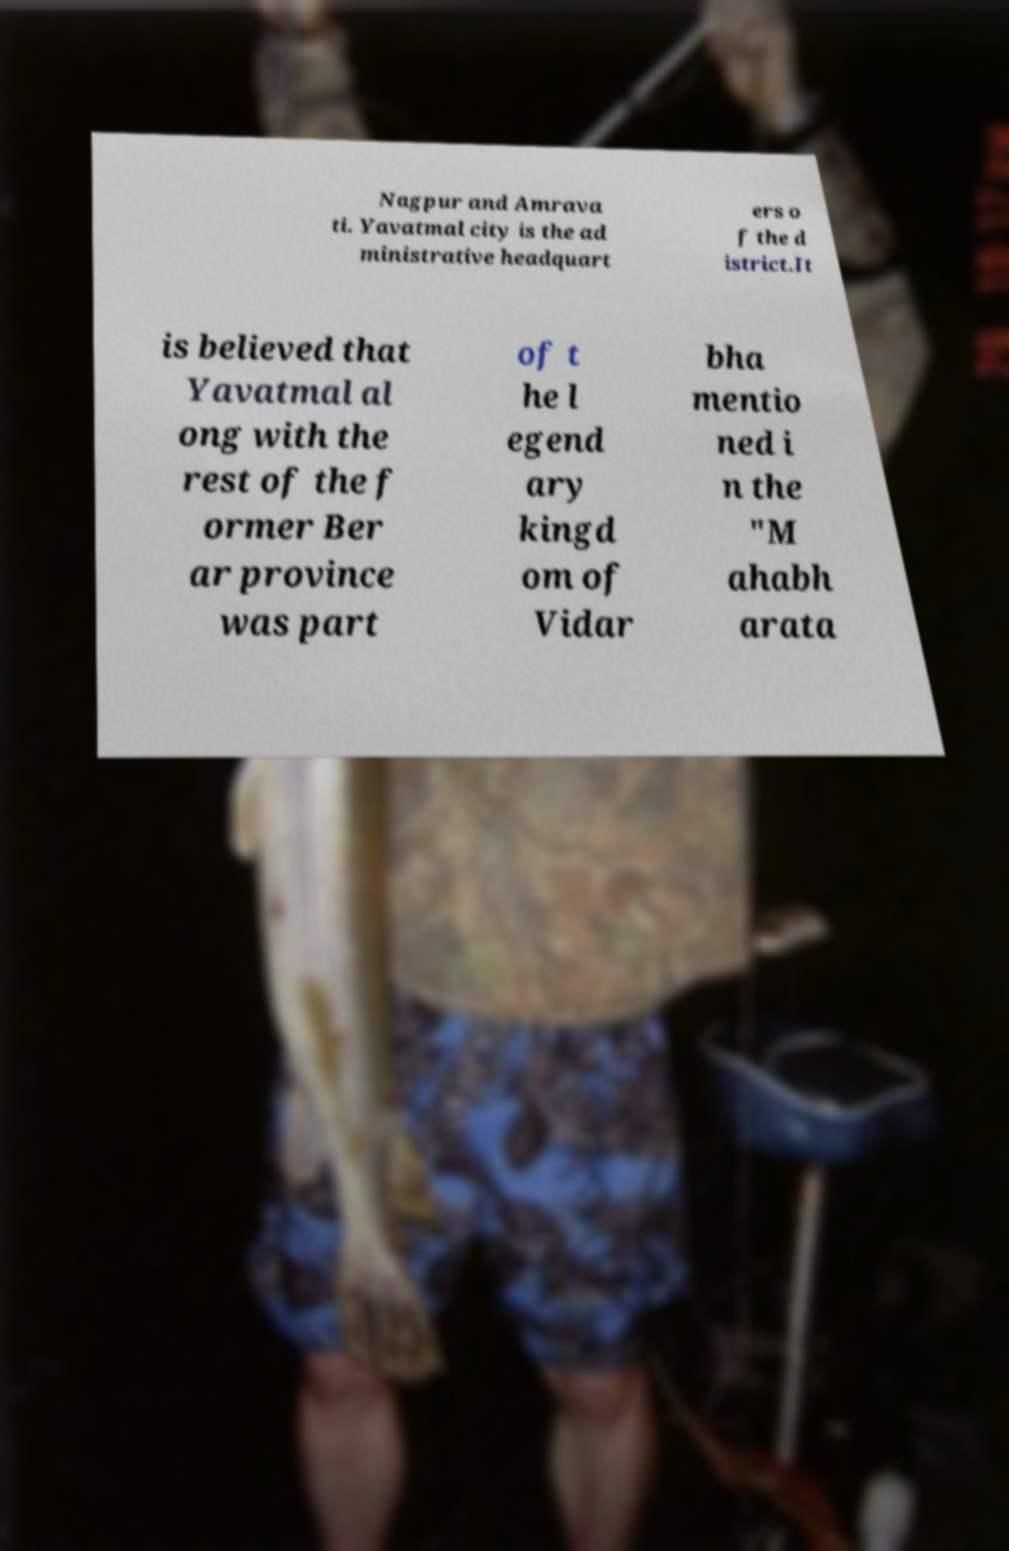Could you assist in decoding the text presented in this image and type it out clearly? Nagpur and Amrava ti. Yavatmal city is the ad ministrative headquart ers o f the d istrict.It is believed that Yavatmal al ong with the rest of the f ormer Ber ar province was part of t he l egend ary kingd om of Vidar bha mentio ned i n the "M ahabh arata 